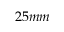Convert formula to latex. <formula><loc_0><loc_0><loc_500><loc_500>2 5 m m</formula> 